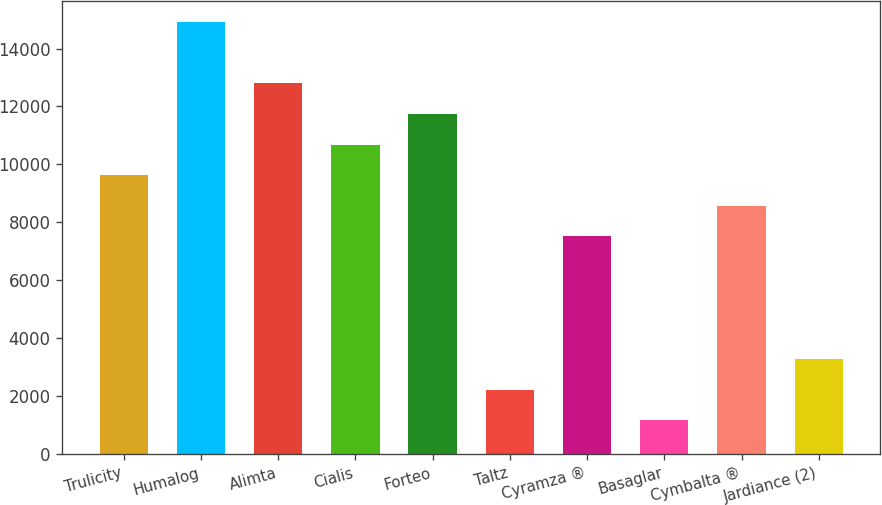<chart> <loc_0><loc_0><loc_500><loc_500><bar_chart><fcel>Trulicity<fcel>Humalog<fcel>Alimta<fcel>Cialis<fcel>Forteo<fcel>Taltz<fcel>Cyramza ®<fcel>Basaglar<fcel>Cymbalta ®<fcel>Jardiance (2)<nl><fcel>9622.83<fcel>14911.2<fcel>12795.8<fcel>10680.5<fcel>11738.2<fcel>2219.14<fcel>7507.49<fcel>1161.47<fcel>8565.16<fcel>3276.81<nl></chart> 